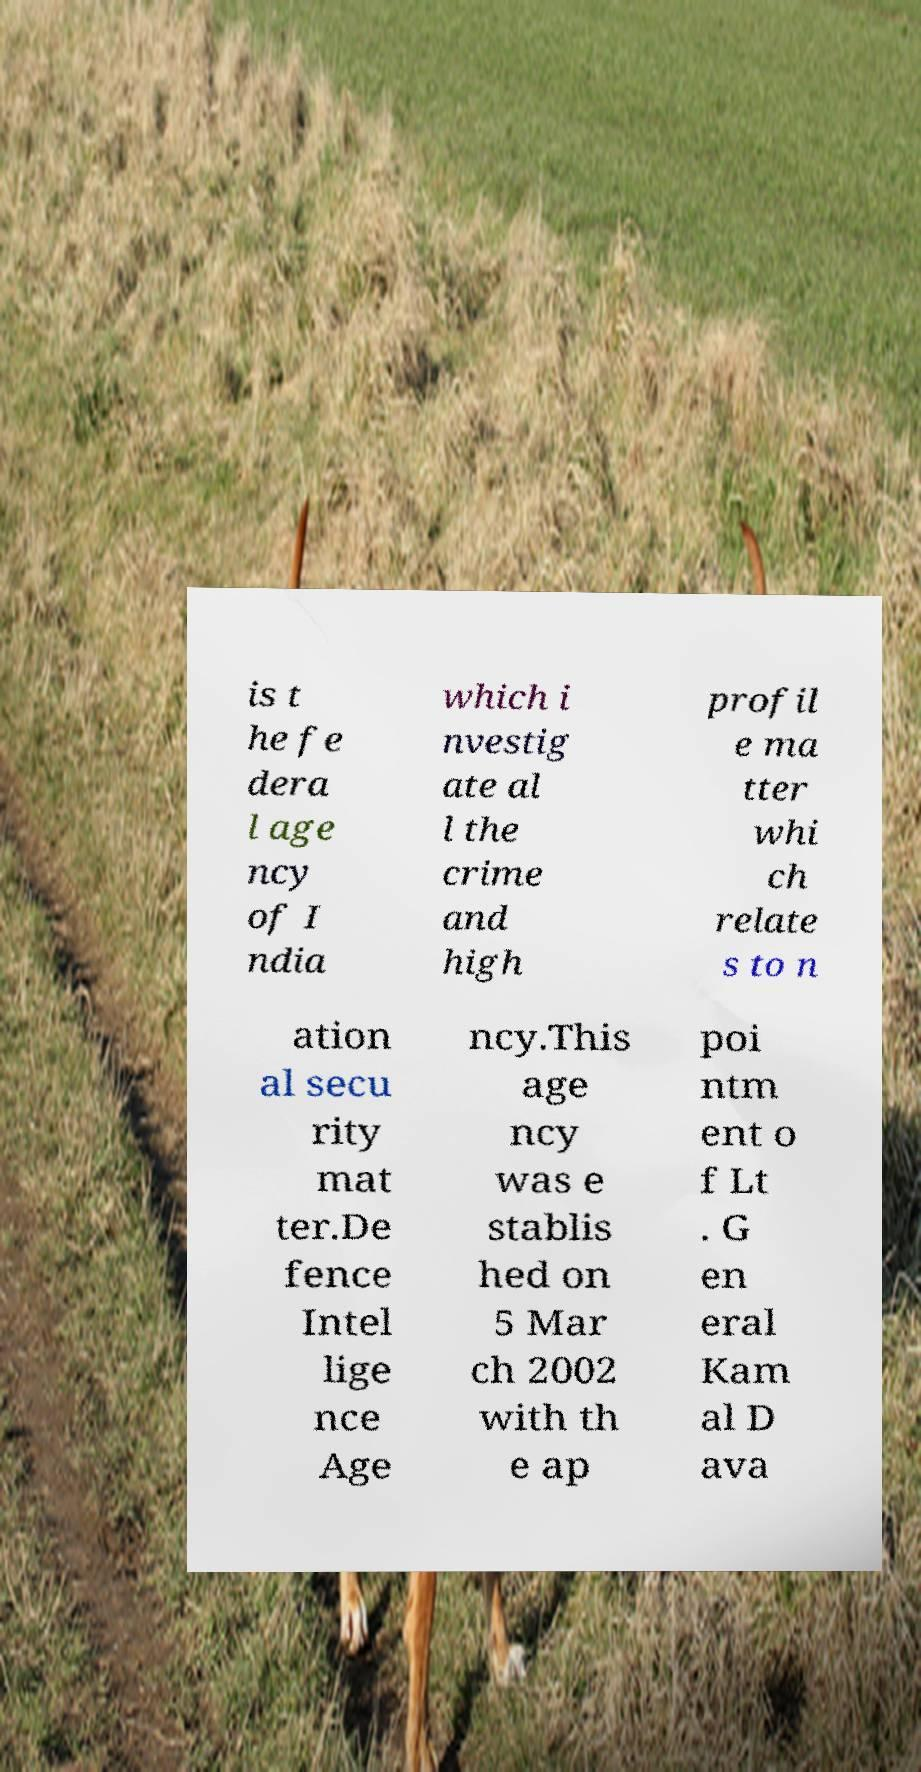There's text embedded in this image that I need extracted. Can you transcribe it verbatim? is t he fe dera l age ncy of I ndia which i nvestig ate al l the crime and high profil e ma tter whi ch relate s to n ation al secu rity mat ter.De fence Intel lige nce Age ncy.This age ncy was e stablis hed on 5 Mar ch 2002 with th e ap poi ntm ent o f Lt . G en eral Kam al D ava 